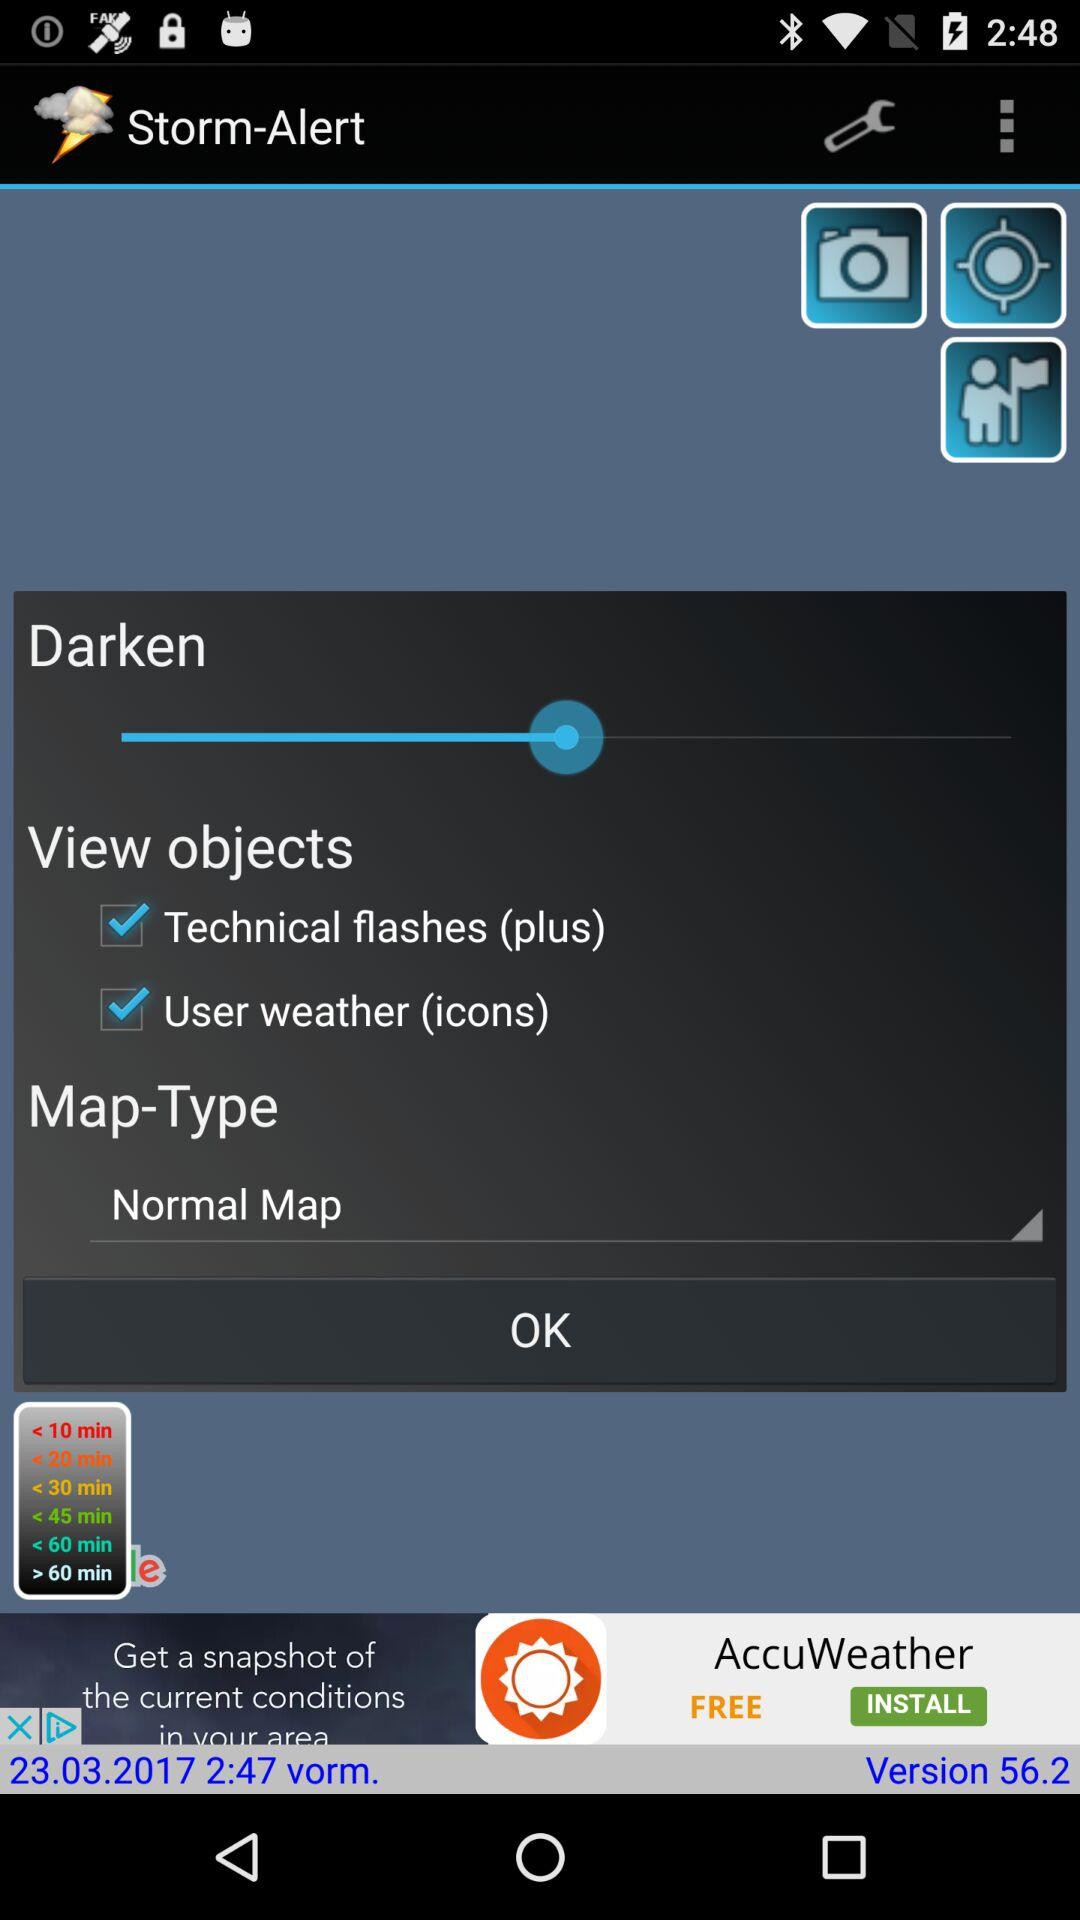What is the map-type? The map-type is "Normal Map". 